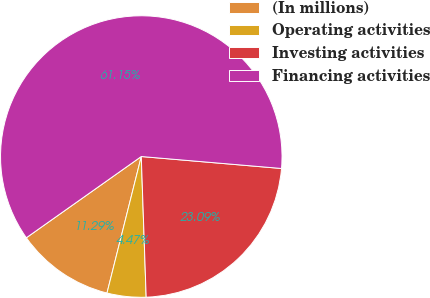Convert chart to OTSL. <chart><loc_0><loc_0><loc_500><loc_500><pie_chart><fcel>(In millions)<fcel>Operating activities<fcel>Investing activities<fcel>Financing activities<nl><fcel>11.29%<fcel>4.47%<fcel>23.09%<fcel>61.14%<nl></chart> 